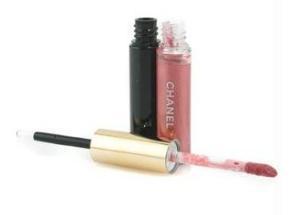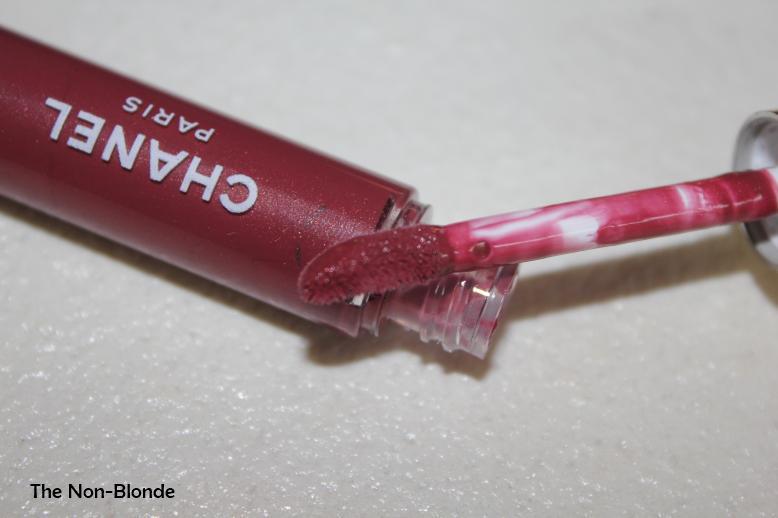The first image is the image on the left, the second image is the image on the right. Assess this claim about the two images: "The left image contains an uncapped lipstick wand, and the right image includes at least one capped lip makeup.". Correct or not? Answer yes or no. No. The first image is the image on the left, the second image is the image on the right. Evaluate the accuracy of this statement regarding the images: "there is a black bottle with an open lip gloss wand with a gold handle". Is it true? Answer yes or no. Yes. 